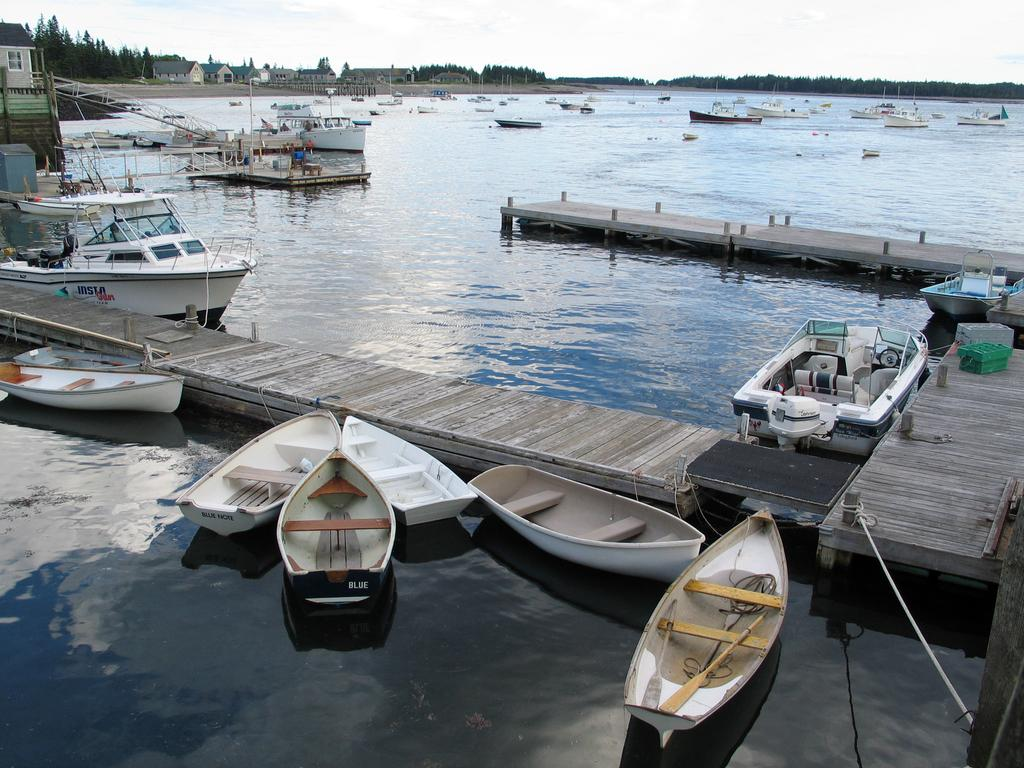What can be seen in the foreground of the image? In the foreground of the image, there are boats, a road, and a fence in the water. What is visible in the background of the image? In the background of the image, there are trees, houses, poles, and the sky. Can you describe the setting of the image? The image may have been taken near a lake, as there is water in the foreground and boats are present. How many types of structures are visible in the background? There are three types of structures visible in the background: trees, houses, and poles. What organization is responsible for maintaining the peace in the image? There is no indication of any organization or peacekeeping efforts in the image. What type of cover is provided by the trees in the image? The trees in the image do not provide any cover, as they are in the background and not directly over any objects or people. 